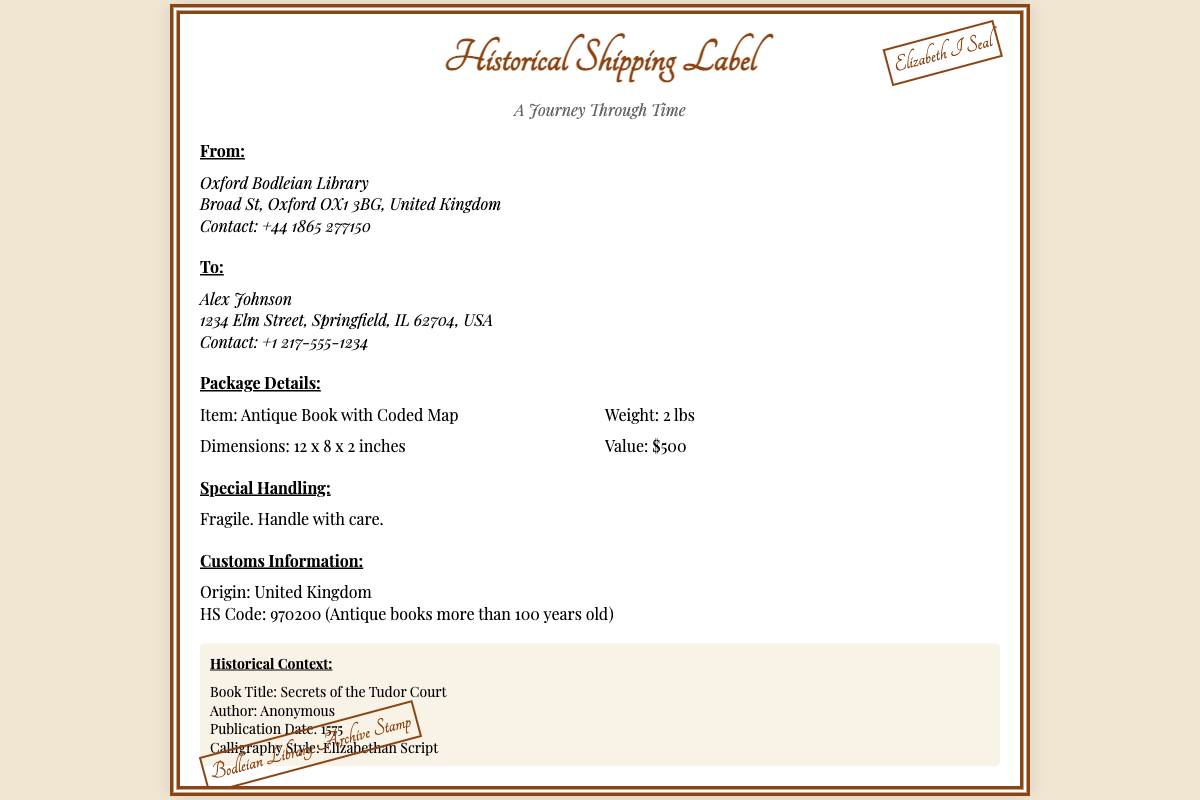What is the sender's name? The sender is identified in the "From" section of the document.
Answer: Oxford Bodleian Library What is the recipient's address? The address of the recipient is found in the "To" section.
Answer: 1234 Elm Street, Springfield, IL 62704, USA What is the item being shipped? The item is specified in the "Package Details" section of the document.
Answer: Antique Book with Coded Map What is the weight of the package? The weight information is included in the "Package Details" section.
Answer: 2 lbs What is the value of the item? The value is provided in the "Package Details" section.
Answer: $500 What is the historical context book title? The title of the book is given in the "Historical Context" section.
Answer: Secrets of the Tudor Court What year was the book published? The publication date can be found in the "Historical Context" section.
Answer: 1575 What type of handling is specified for the package? The specific handling instructions are listed in the "Special Handling" section.
Answer: Fragile. Handle with care What is the HS Code mentioned? The HS Code can be found in the "Customs Information" section.
Answer: 970200 What stamp is present from the sender? The stamps listed at the bottom of the document indicate the official seals.
Answer: Elizabeth I Seal 